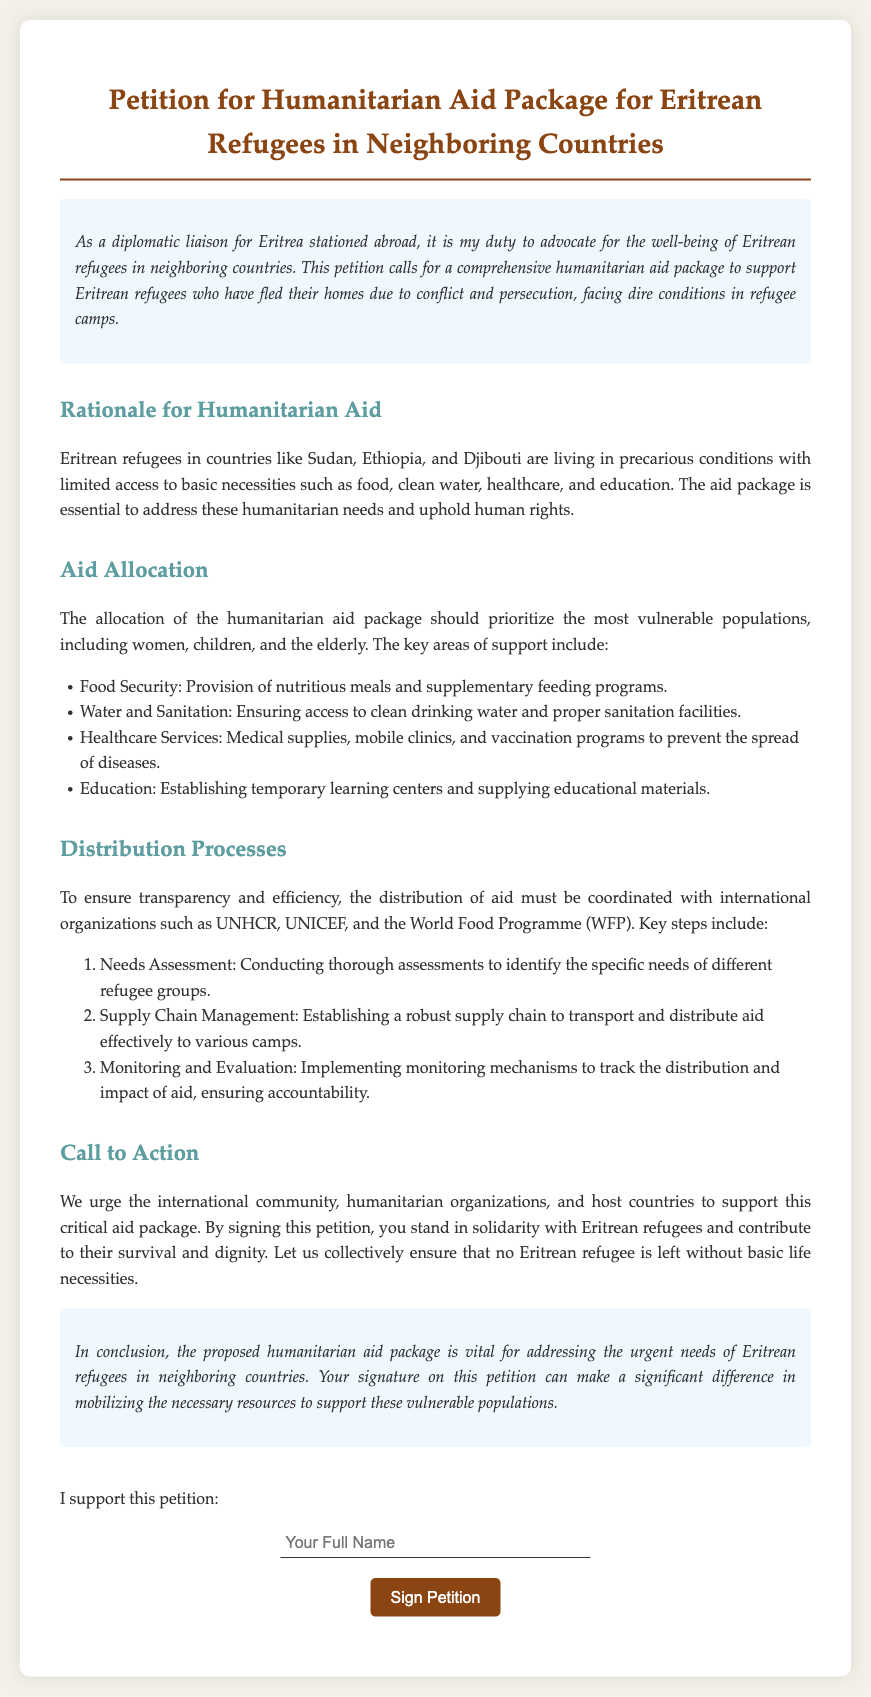What is the main purpose of the petition? The petition aims to advocate for a comprehensive humanitarian aid package to support Eritrean refugees facing dire conditions.
Answer: Humanitarian aid package Which countries are mentioned where Eritrean refugees are located? The document specifies the countries where Eritrean refugees are living in precarious conditions.
Answer: Sudan, Ethiopia, Djibouti What key area of support is related to hygiene? The document outlines areas of aid that support refugees' basic needs, including cleanliness.
Answer: Water and Sanitation What is the first step in the distribution process? The distribution process includes key steps to ensure effective aid distribution, the first of which is identified in the document.
Answer: Needs Assessment Who are the targeted vulnerable populations for the aid package? The document identifies specific groups of refugees who should be prioritized, highlighting the most vulnerable.
Answer: Women, children, and the elderly Which organizations should aid distribution be coordinated with? The document lists organizations that should be involved in coordinating the humanitarian aid distribution.
Answer: UNHCR, UNICEF, and WFP What is the ultimate call to action in the petition? The petition concludes by urging certain groups to take specific action regarding the aid package.
Answer: Support this critical aid package What is one form of aid mentioned for healthcare services? The document lists specific healthcare-related support included in the aid package.
Answer: Medical supplies 